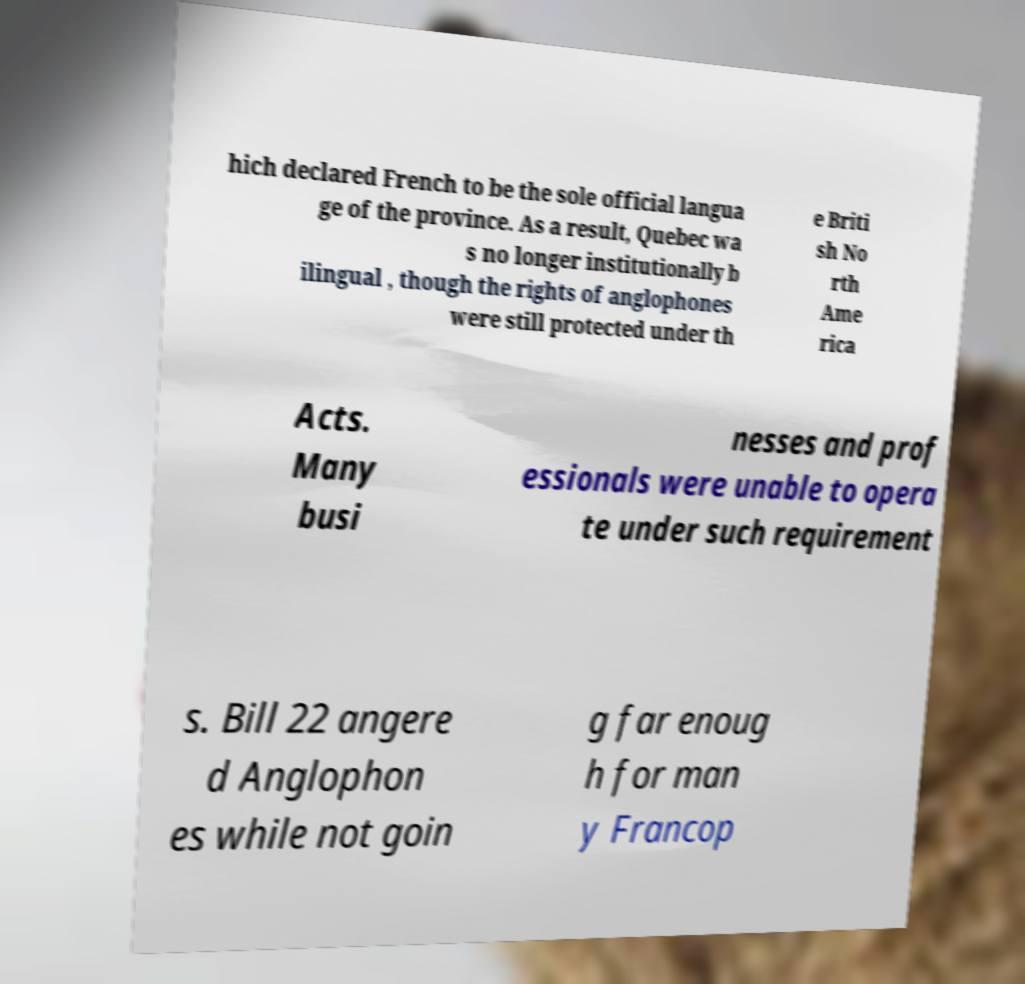Could you extract and type out the text from this image? hich declared French to be the sole official langua ge of the province. As a result, Quebec wa s no longer institutionally b ilingual , though the rights of anglophones were still protected under th e Briti sh No rth Ame rica Acts. Many busi nesses and prof essionals were unable to opera te under such requirement s. Bill 22 angere d Anglophon es while not goin g far enoug h for man y Francop 